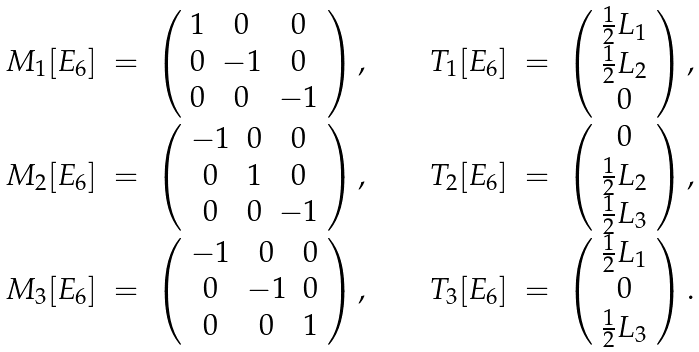<formula> <loc_0><loc_0><loc_500><loc_500>\begin{array} { r c l c r c l } M _ { 1 } { [ E _ { 6 } ] } & = & \left ( \begin{array} { c c c } 1 & 0 & 0 \\ 0 & - 1 & 0 \\ 0 & 0 & - 1 \end{array} \right ) , & \quad & T _ { 1 } [ E _ { 6 } ] & = & \left ( \begin{array} { c } \frac { 1 } { 2 } L _ { 1 } \\ \frac { 1 } { 2 } L _ { 2 } \\ 0 \end{array} \right ) , \\ M _ { 2 } { [ E _ { 6 } ] } & = & \left ( \begin{array} { c c c } - 1 & 0 & 0 \\ 0 & 1 & 0 \\ 0 & 0 & - 1 \end{array} \right ) , & \quad & T _ { 2 } [ E _ { 6 } ] & = & \left ( \begin{array} { c } 0 \\ \frac { 1 } { 2 } L _ { 2 } \\ \frac { 1 } { 2 } L _ { 3 } \end{array} \right ) , \\ M _ { 3 } { [ E _ { 6 } ] } & = & \left ( \begin{array} { c c c } - 1 & 0 & 0 \\ 0 & - 1 & 0 \\ 0 & 0 & 1 \end{array} \right ) , & \quad & T _ { 3 } [ E _ { 6 } ] & = & \left ( \begin{array} { c } \frac { 1 } { 2 } L _ { 1 } \\ 0 \\ \frac { 1 } { 2 } L _ { 3 } \end{array} \right ) . \end{array}</formula> 